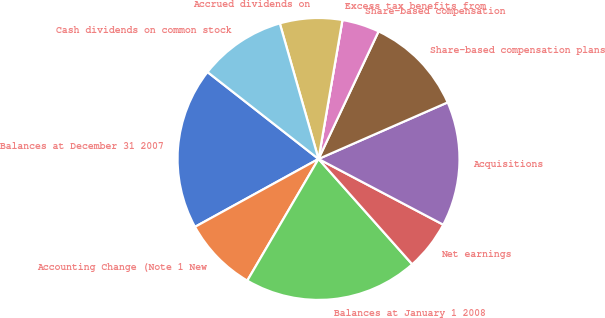Convert chart. <chart><loc_0><loc_0><loc_500><loc_500><pie_chart><fcel>Balances at December 31 2007<fcel>Accounting Change (Note 1 New<fcel>Balances at January 1 2008<fcel>Net earnings<fcel>Acquisitions<fcel>Share-based compensation plans<fcel>Share-based compensation<fcel>Excess tax benefits from<fcel>Accrued dividends on<fcel>Cash dividends on common stock<nl><fcel>18.57%<fcel>8.57%<fcel>20.0%<fcel>5.71%<fcel>14.29%<fcel>11.43%<fcel>4.29%<fcel>0.0%<fcel>7.14%<fcel>10.0%<nl></chart> 